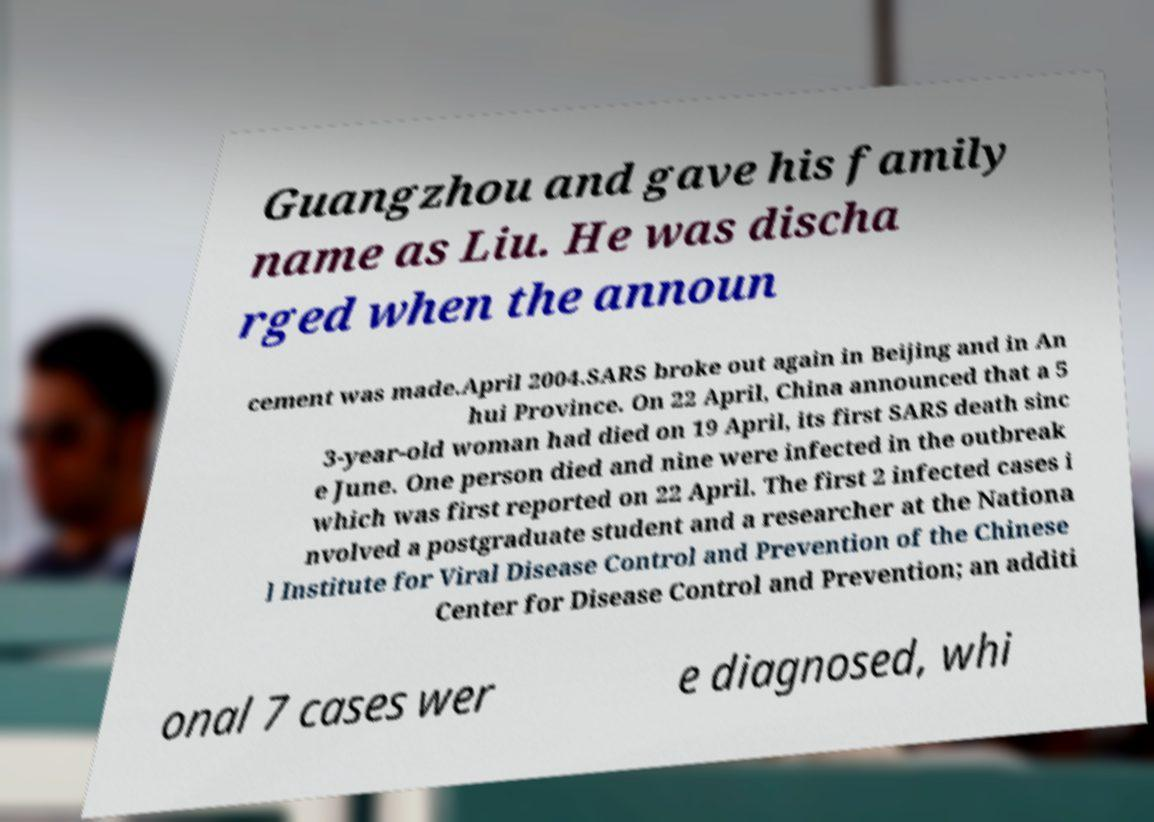Can you read and provide the text displayed in the image?This photo seems to have some interesting text. Can you extract and type it out for me? Guangzhou and gave his family name as Liu. He was discha rged when the announ cement was made.April 2004.SARS broke out again in Beijing and in An hui Province. On 22 April, China announced that a 5 3-year-old woman had died on 19 April, its first SARS death sinc e June. One person died and nine were infected in the outbreak which was first reported on 22 April. The first 2 infected cases i nvolved a postgraduate student and a researcher at the Nationa l Institute for Viral Disease Control and Prevention of the Chinese Center for Disease Control and Prevention; an additi onal 7 cases wer e diagnosed, whi 